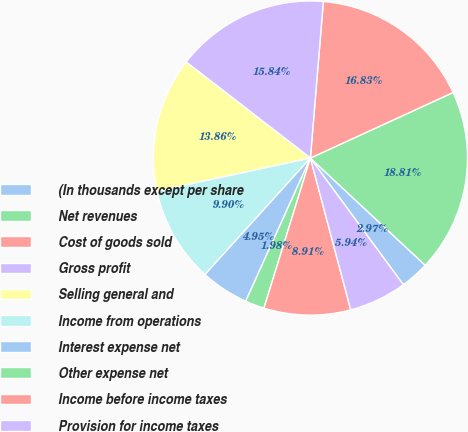Convert chart to OTSL. <chart><loc_0><loc_0><loc_500><loc_500><pie_chart><fcel>(In thousands except per share<fcel>Net revenues<fcel>Cost of goods sold<fcel>Gross profit<fcel>Selling general and<fcel>Income from operations<fcel>Interest expense net<fcel>Other expense net<fcel>Income before income taxes<fcel>Provision for income taxes<nl><fcel>2.97%<fcel>18.81%<fcel>16.83%<fcel>15.84%<fcel>13.86%<fcel>9.9%<fcel>4.95%<fcel>1.98%<fcel>8.91%<fcel>5.94%<nl></chart> 